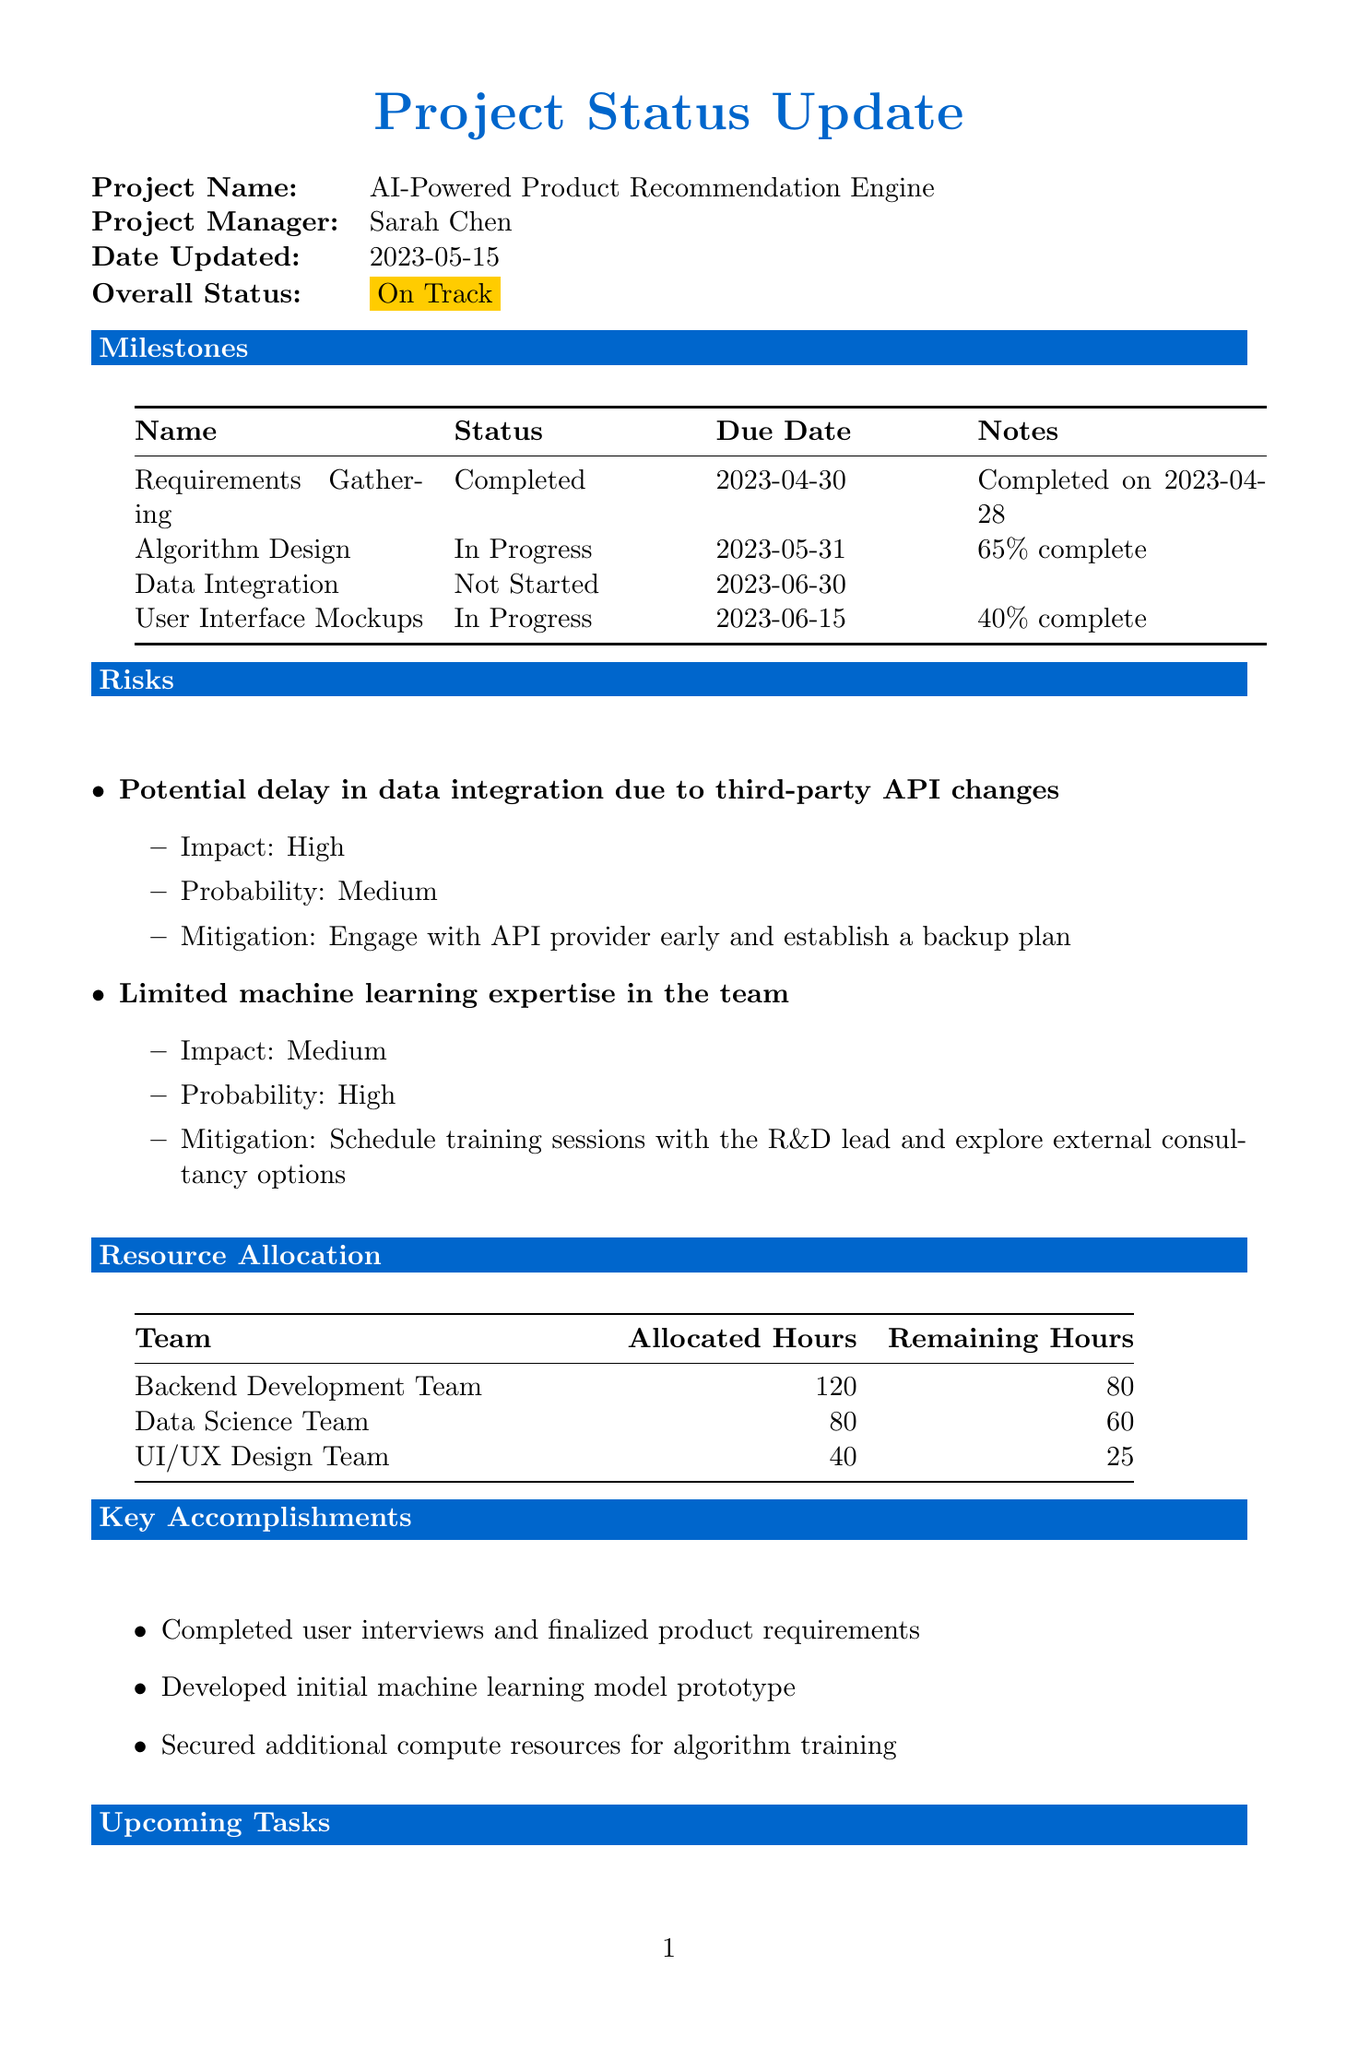What is the project name? The project name is explicitly stated at the beginning of the document.
Answer: AI-Powered Product Recommendation Engine Who is the project manager? The document specifies the project manager's name in the project details section.
Answer: Sarah Chen What is the overall status of the project? The overall status is highlighted in the project details, indicating the project's current condition.
Answer: On Track What is the due date for the Algorithm Design milestone? The due date is listed in the milestones section, associated with the specific task.
Answer: 2023-05-31 What percentage complete is the User Interface Mockups milestone? The percentage complete for the milestone is mentioned in the milestones section, indicating progress.
Answer: 40% What is the impact of the risk related to limited machine learning expertise? The impact of this risk is described in the risks section, indicating its severity.
Answer: Medium How many allocated hours does the Data Science Team have? The allocated hours for the Data Science Team are listed in the resource allocation section.
Answer: 80 What is the mitigation plan for the risk related to potential delay in data integration? The document includes a specific mitigation plan for this identified risk in the risks section.
Answer: Engage with API provider early and establish a backup plan What is one upcoming task mentioned? The upcoming tasks are clearly outlined in the upcoming tasks section, detailing future actions.
Answer: Finalize algorithm design with R&D lead's input 